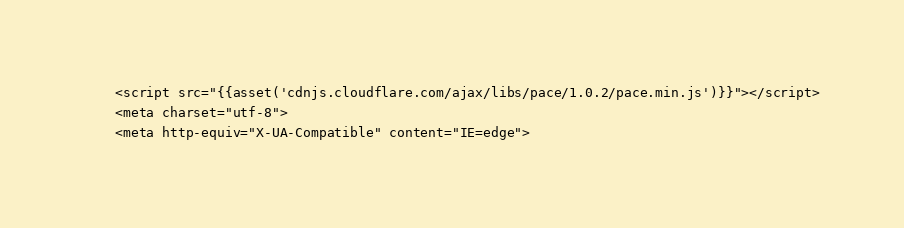<code> <loc_0><loc_0><loc_500><loc_500><_PHP_>    <script src="{{asset('cdnjs.cloudflare.com/ajax/libs/pace/1.0.2/pace.min.js')}}"></script>
    <meta charset="utf-8">
    <meta http-equiv="X-UA-Compatible" content="IE=edge"></code> 